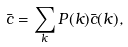<formula> <loc_0><loc_0><loc_500><loc_500>\bar { c } = \sum _ { k } P ( k ) \bar { c } ( k ) ,</formula> 